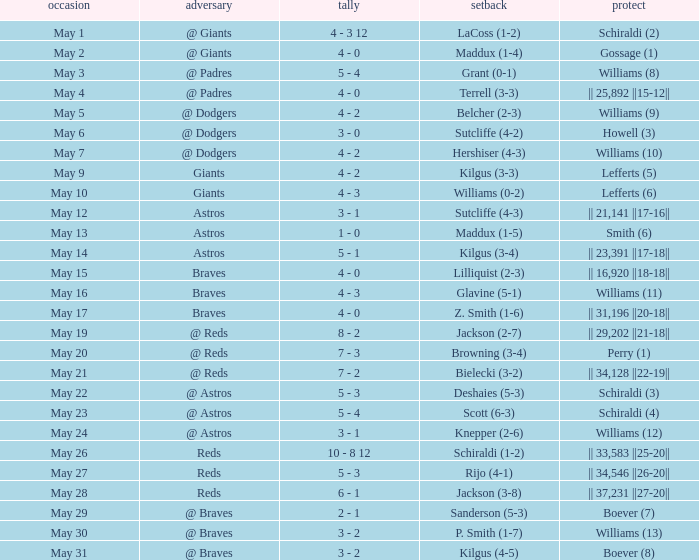Name the save for braves for may 15 || 16,920 ||18-18||. 